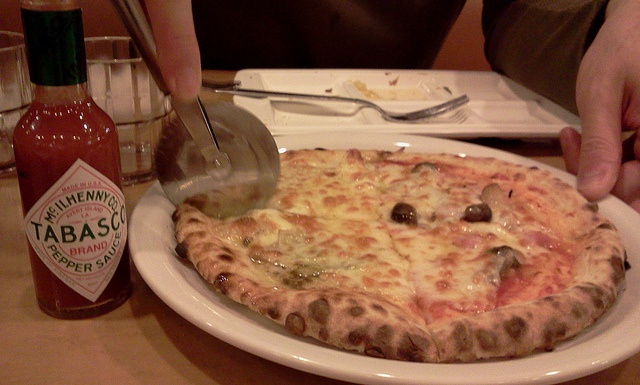Describe the objects in this image and their specific colors. I can see pizza in maroon, tan, salmon, and brown tones, people in maroon, black, and brown tones, bottle in maroon, black, and brown tones, dining table in maroon and brown tones, and cup in maroon, brown, gray, and black tones in this image. 